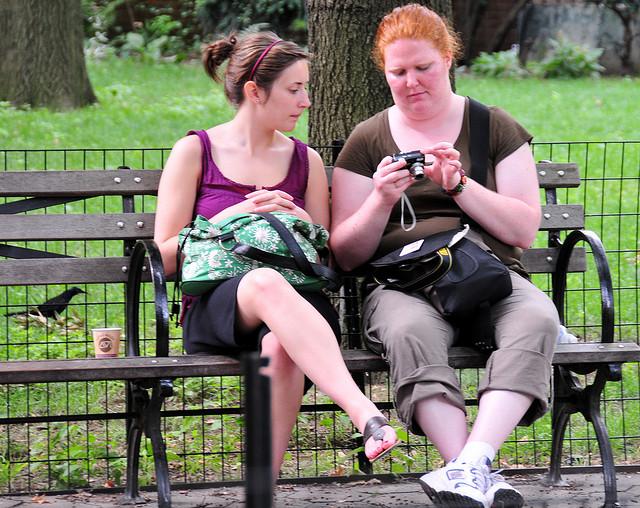Where is the bird?
Concise answer only. Grass. Is there a tree behind the women?
Answer briefly. Yes. What are the ladies looking at?
Quick response, please. Camera. 